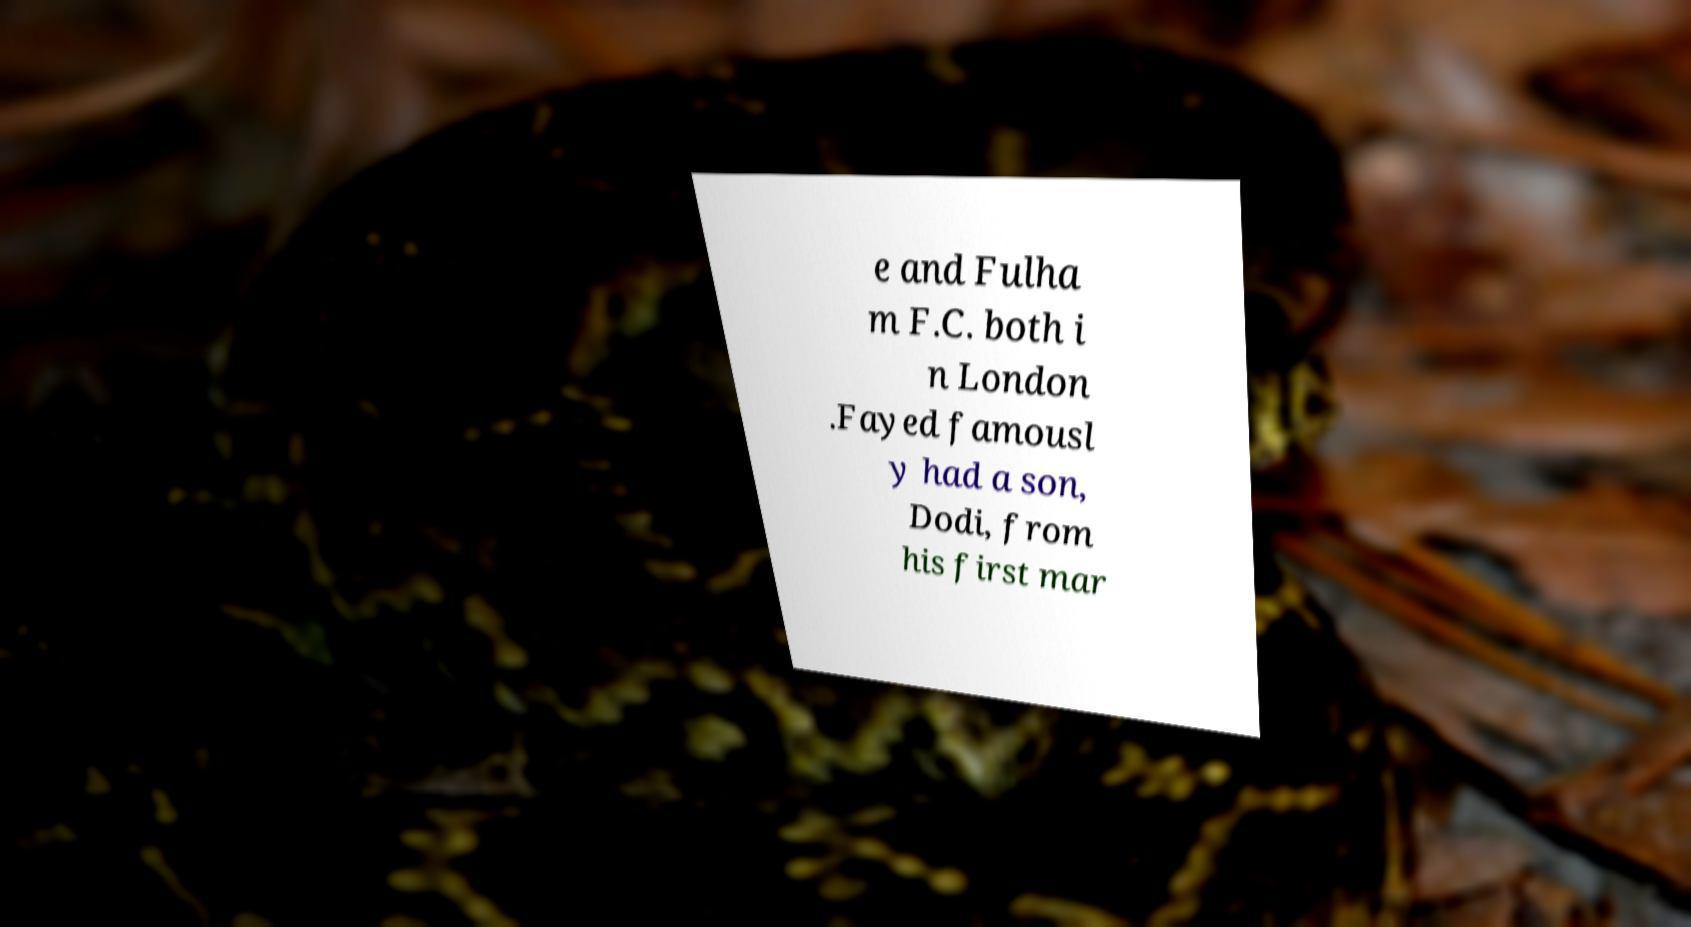Please read and relay the text visible in this image. What does it say? e and Fulha m F.C. both i n London .Fayed famousl y had a son, Dodi, from his first mar 